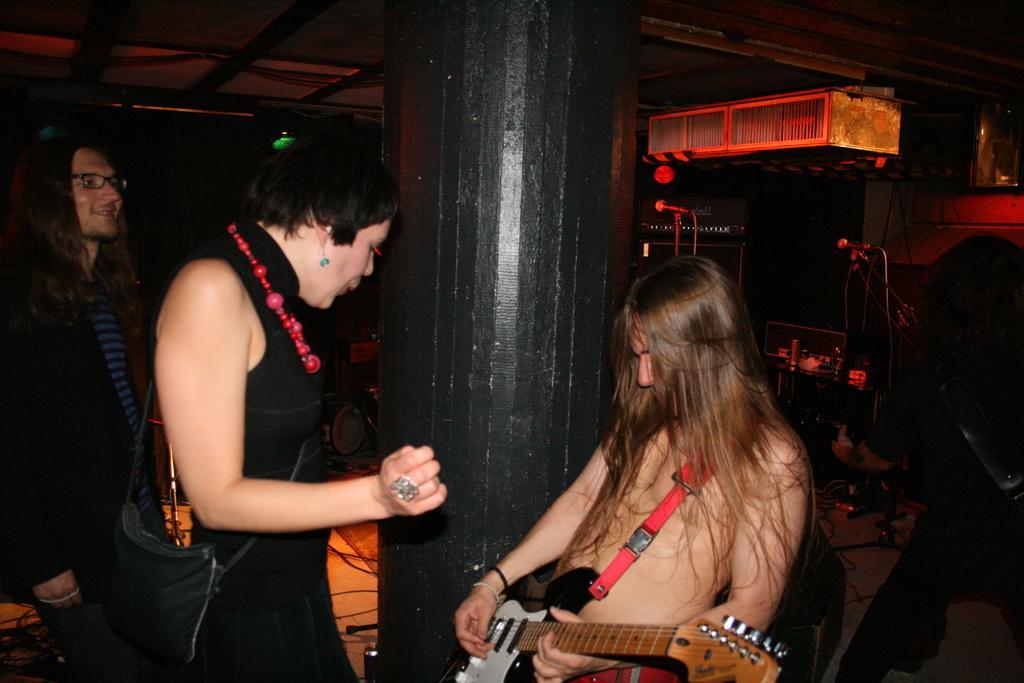Describe this image in one or two sentences. In this picture we can see three persons. He is playing guitar. This is a pillar. Here we can see miles and these are some musical instruments. 